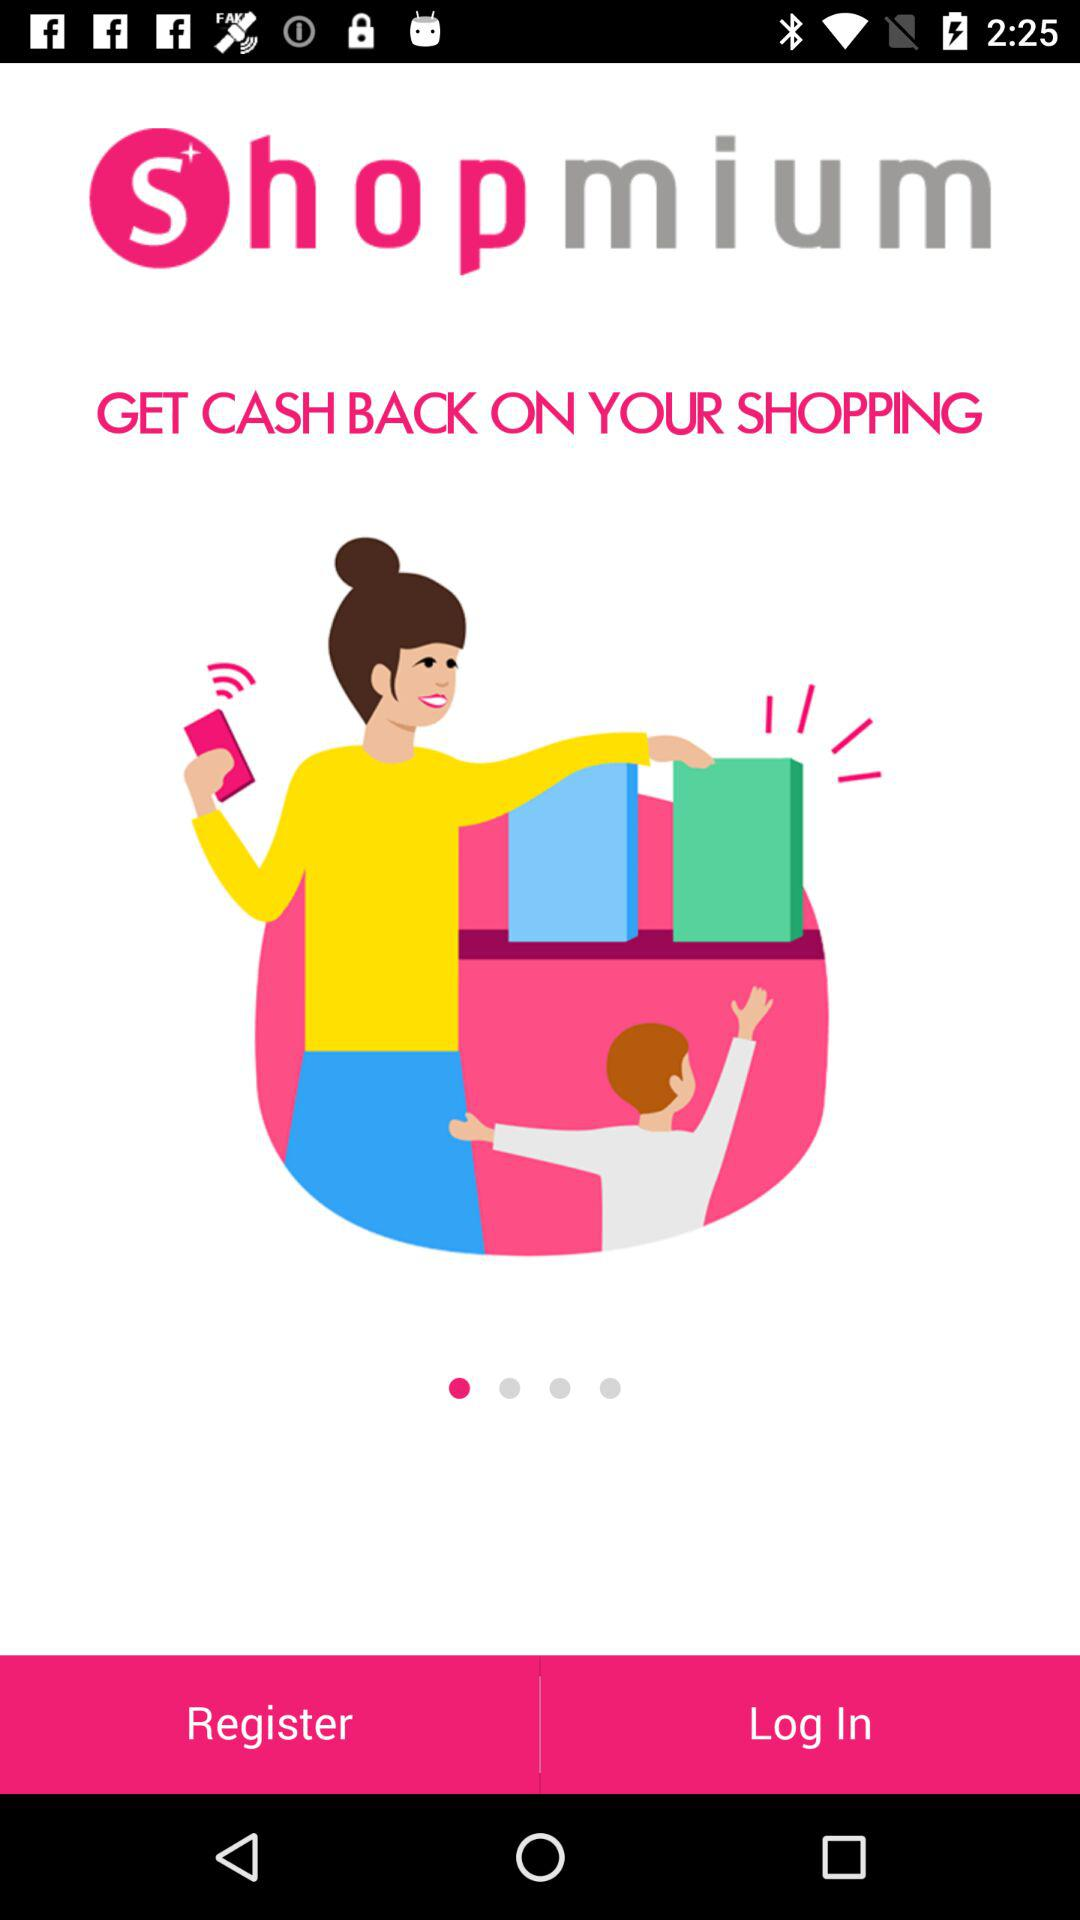What is the application name? The application name is "shopmium". 